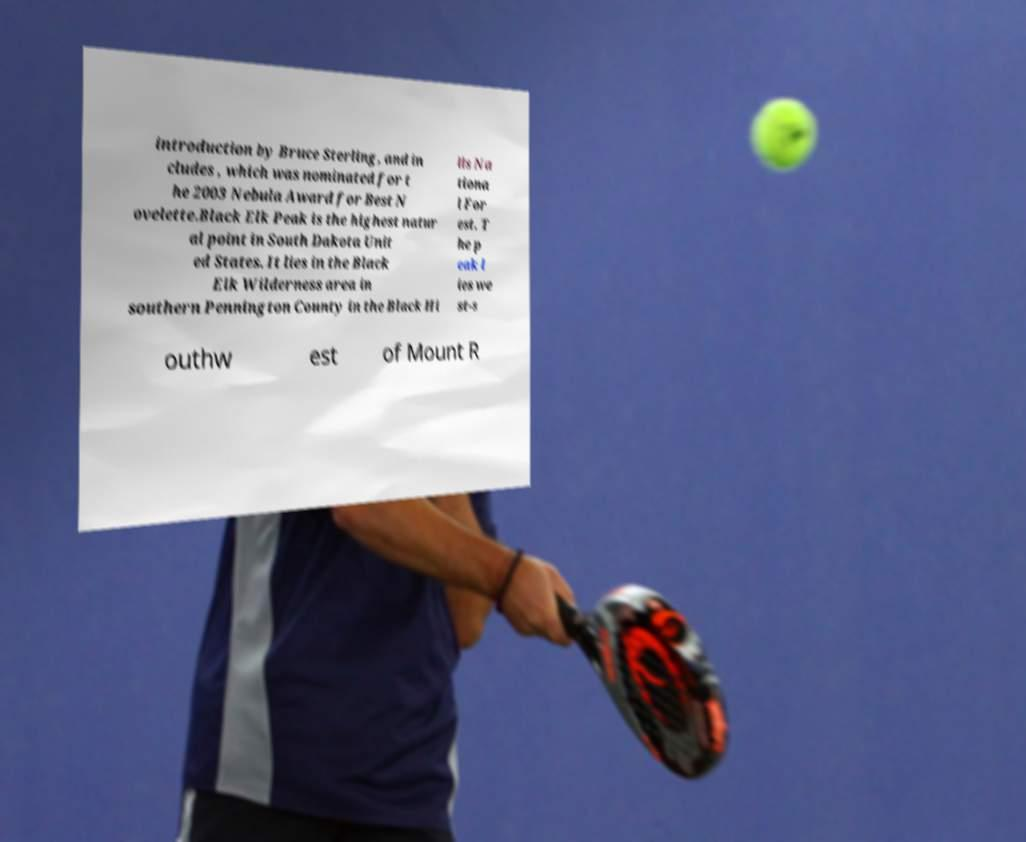Please identify and transcribe the text found in this image. introduction by Bruce Sterling, and in cludes , which was nominated for t he 2003 Nebula Award for Best N ovelette.Black Elk Peak is the highest natur al point in South Dakota Unit ed States. It lies in the Black Elk Wilderness area in southern Pennington County in the Black Hi lls Na tiona l For est. T he p eak l ies we st-s outhw est of Mount R 